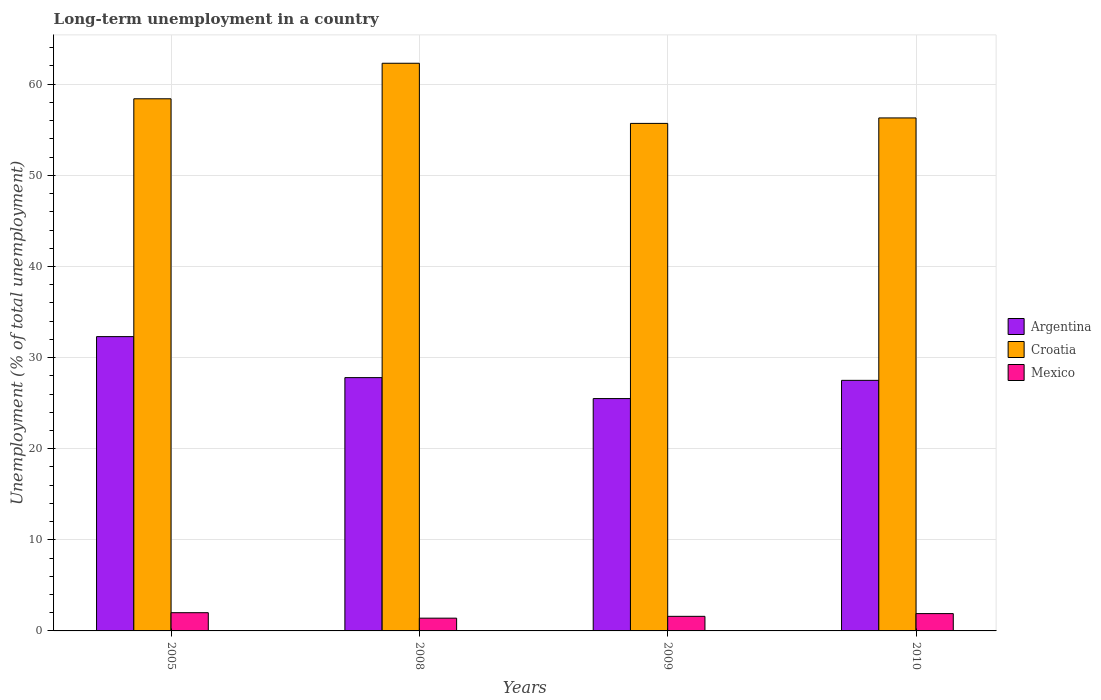How many different coloured bars are there?
Provide a short and direct response. 3. How many groups of bars are there?
Your answer should be compact. 4. Are the number of bars per tick equal to the number of legend labels?
Make the answer very short. Yes. Are the number of bars on each tick of the X-axis equal?
Provide a succinct answer. Yes. How many bars are there on the 4th tick from the right?
Your response must be concise. 3. What is the label of the 3rd group of bars from the left?
Make the answer very short. 2009. In how many cases, is the number of bars for a given year not equal to the number of legend labels?
Your response must be concise. 0. What is the percentage of long-term unemployed population in Mexico in 2010?
Provide a short and direct response. 1.9. Across all years, what is the maximum percentage of long-term unemployed population in Argentina?
Keep it short and to the point. 32.3. Across all years, what is the minimum percentage of long-term unemployed population in Mexico?
Make the answer very short. 1.4. In which year was the percentage of long-term unemployed population in Argentina minimum?
Ensure brevity in your answer.  2009. What is the total percentage of long-term unemployed population in Mexico in the graph?
Your response must be concise. 6.9. What is the difference between the percentage of long-term unemployed population in Croatia in 2008 and that in 2009?
Offer a terse response. 6.6. What is the difference between the percentage of long-term unemployed population in Mexico in 2008 and the percentage of long-term unemployed population in Croatia in 2010?
Offer a very short reply. -54.9. What is the average percentage of long-term unemployed population in Croatia per year?
Your response must be concise. 58.18. In the year 2009, what is the difference between the percentage of long-term unemployed population in Argentina and percentage of long-term unemployed population in Croatia?
Your response must be concise. -30.2. In how many years, is the percentage of long-term unemployed population in Mexico greater than 50 %?
Your answer should be very brief. 0. What is the ratio of the percentage of long-term unemployed population in Croatia in 2009 to that in 2010?
Provide a succinct answer. 0.99. What is the difference between the highest and the second highest percentage of long-term unemployed population in Mexico?
Provide a succinct answer. 0.1. What is the difference between the highest and the lowest percentage of long-term unemployed population in Mexico?
Keep it short and to the point. 0.6. Is it the case that in every year, the sum of the percentage of long-term unemployed population in Croatia and percentage of long-term unemployed population in Argentina is greater than the percentage of long-term unemployed population in Mexico?
Offer a very short reply. Yes. How many bars are there?
Your answer should be compact. 12. Are the values on the major ticks of Y-axis written in scientific E-notation?
Provide a short and direct response. No. Does the graph contain any zero values?
Offer a terse response. No. Does the graph contain grids?
Provide a succinct answer. Yes. Where does the legend appear in the graph?
Offer a terse response. Center right. How many legend labels are there?
Offer a terse response. 3. What is the title of the graph?
Provide a succinct answer. Long-term unemployment in a country. Does "Bosnia and Herzegovina" appear as one of the legend labels in the graph?
Keep it short and to the point. No. What is the label or title of the X-axis?
Your answer should be very brief. Years. What is the label or title of the Y-axis?
Offer a very short reply. Unemployment (% of total unemployment). What is the Unemployment (% of total unemployment) of Argentina in 2005?
Give a very brief answer. 32.3. What is the Unemployment (% of total unemployment) of Croatia in 2005?
Ensure brevity in your answer.  58.4. What is the Unemployment (% of total unemployment) of Mexico in 2005?
Offer a very short reply. 2. What is the Unemployment (% of total unemployment) of Argentina in 2008?
Make the answer very short. 27.8. What is the Unemployment (% of total unemployment) in Croatia in 2008?
Provide a succinct answer. 62.3. What is the Unemployment (% of total unemployment) in Mexico in 2008?
Offer a very short reply. 1.4. What is the Unemployment (% of total unemployment) in Croatia in 2009?
Your response must be concise. 55.7. What is the Unemployment (% of total unemployment) of Mexico in 2009?
Offer a very short reply. 1.6. What is the Unemployment (% of total unemployment) in Croatia in 2010?
Offer a very short reply. 56.3. What is the Unemployment (% of total unemployment) in Mexico in 2010?
Provide a short and direct response. 1.9. Across all years, what is the maximum Unemployment (% of total unemployment) in Argentina?
Provide a short and direct response. 32.3. Across all years, what is the maximum Unemployment (% of total unemployment) of Croatia?
Give a very brief answer. 62.3. Across all years, what is the maximum Unemployment (% of total unemployment) of Mexico?
Offer a terse response. 2. Across all years, what is the minimum Unemployment (% of total unemployment) of Croatia?
Offer a very short reply. 55.7. Across all years, what is the minimum Unemployment (% of total unemployment) of Mexico?
Provide a short and direct response. 1.4. What is the total Unemployment (% of total unemployment) of Argentina in the graph?
Ensure brevity in your answer.  113.1. What is the total Unemployment (% of total unemployment) in Croatia in the graph?
Provide a short and direct response. 232.7. What is the total Unemployment (% of total unemployment) in Mexico in the graph?
Offer a terse response. 6.9. What is the difference between the Unemployment (% of total unemployment) of Croatia in 2005 and that in 2008?
Give a very brief answer. -3.9. What is the difference between the Unemployment (% of total unemployment) of Mexico in 2005 and that in 2009?
Provide a short and direct response. 0.4. What is the difference between the Unemployment (% of total unemployment) of Argentina in 2005 and that in 2010?
Offer a terse response. 4.8. What is the difference between the Unemployment (% of total unemployment) of Argentina in 2008 and that in 2009?
Provide a short and direct response. 2.3. What is the difference between the Unemployment (% of total unemployment) in Mexico in 2008 and that in 2010?
Ensure brevity in your answer.  -0.5. What is the difference between the Unemployment (% of total unemployment) in Mexico in 2009 and that in 2010?
Your response must be concise. -0.3. What is the difference between the Unemployment (% of total unemployment) of Argentina in 2005 and the Unemployment (% of total unemployment) of Mexico in 2008?
Offer a terse response. 30.9. What is the difference between the Unemployment (% of total unemployment) in Croatia in 2005 and the Unemployment (% of total unemployment) in Mexico in 2008?
Provide a short and direct response. 57. What is the difference between the Unemployment (% of total unemployment) of Argentina in 2005 and the Unemployment (% of total unemployment) of Croatia in 2009?
Offer a very short reply. -23.4. What is the difference between the Unemployment (% of total unemployment) of Argentina in 2005 and the Unemployment (% of total unemployment) of Mexico in 2009?
Provide a succinct answer. 30.7. What is the difference between the Unemployment (% of total unemployment) of Croatia in 2005 and the Unemployment (% of total unemployment) of Mexico in 2009?
Provide a succinct answer. 56.8. What is the difference between the Unemployment (% of total unemployment) in Argentina in 2005 and the Unemployment (% of total unemployment) in Croatia in 2010?
Provide a succinct answer. -24. What is the difference between the Unemployment (% of total unemployment) in Argentina in 2005 and the Unemployment (% of total unemployment) in Mexico in 2010?
Provide a short and direct response. 30.4. What is the difference between the Unemployment (% of total unemployment) in Croatia in 2005 and the Unemployment (% of total unemployment) in Mexico in 2010?
Your response must be concise. 56.5. What is the difference between the Unemployment (% of total unemployment) in Argentina in 2008 and the Unemployment (% of total unemployment) in Croatia in 2009?
Ensure brevity in your answer.  -27.9. What is the difference between the Unemployment (% of total unemployment) of Argentina in 2008 and the Unemployment (% of total unemployment) of Mexico in 2009?
Your response must be concise. 26.2. What is the difference between the Unemployment (% of total unemployment) in Croatia in 2008 and the Unemployment (% of total unemployment) in Mexico in 2009?
Offer a terse response. 60.7. What is the difference between the Unemployment (% of total unemployment) in Argentina in 2008 and the Unemployment (% of total unemployment) in Croatia in 2010?
Offer a terse response. -28.5. What is the difference between the Unemployment (% of total unemployment) in Argentina in 2008 and the Unemployment (% of total unemployment) in Mexico in 2010?
Keep it short and to the point. 25.9. What is the difference between the Unemployment (% of total unemployment) in Croatia in 2008 and the Unemployment (% of total unemployment) in Mexico in 2010?
Provide a short and direct response. 60.4. What is the difference between the Unemployment (% of total unemployment) of Argentina in 2009 and the Unemployment (% of total unemployment) of Croatia in 2010?
Make the answer very short. -30.8. What is the difference between the Unemployment (% of total unemployment) of Argentina in 2009 and the Unemployment (% of total unemployment) of Mexico in 2010?
Offer a very short reply. 23.6. What is the difference between the Unemployment (% of total unemployment) in Croatia in 2009 and the Unemployment (% of total unemployment) in Mexico in 2010?
Ensure brevity in your answer.  53.8. What is the average Unemployment (% of total unemployment) in Argentina per year?
Provide a short and direct response. 28.27. What is the average Unemployment (% of total unemployment) of Croatia per year?
Provide a succinct answer. 58.17. What is the average Unemployment (% of total unemployment) of Mexico per year?
Offer a very short reply. 1.73. In the year 2005, what is the difference between the Unemployment (% of total unemployment) in Argentina and Unemployment (% of total unemployment) in Croatia?
Give a very brief answer. -26.1. In the year 2005, what is the difference between the Unemployment (% of total unemployment) of Argentina and Unemployment (% of total unemployment) of Mexico?
Give a very brief answer. 30.3. In the year 2005, what is the difference between the Unemployment (% of total unemployment) of Croatia and Unemployment (% of total unemployment) of Mexico?
Your answer should be compact. 56.4. In the year 2008, what is the difference between the Unemployment (% of total unemployment) of Argentina and Unemployment (% of total unemployment) of Croatia?
Your response must be concise. -34.5. In the year 2008, what is the difference between the Unemployment (% of total unemployment) of Argentina and Unemployment (% of total unemployment) of Mexico?
Your answer should be compact. 26.4. In the year 2008, what is the difference between the Unemployment (% of total unemployment) of Croatia and Unemployment (% of total unemployment) of Mexico?
Your answer should be compact. 60.9. In the year 2009, what is the difference between the Unemployment (% of total unemployment) of Argentina and Unemployment (% of total unemployment) of Croatia?
Ensure brevity in your answer.  -30.2. In the year 2009, what is the difference between the Unemployment (% of total unemployment) in Argentina and Unemployment (% of total unemployment) in Mexico?
Your answer should be very brief. 23.9. In the year 2009, what is the difference between the Unemployment (% of total unemployment) in Croatia and Unemployment (% of total unemployment) in Mexico?
Give a very brief answer. 54.1. In the year 2010, what is the difference between the Unemployment (% of total unemployment) in Argentina and Unemployment (% of total unemployment) in Croatia?
Make the answer very short. -28.8. In the year 2010, what is the difference between the Unemployment (% of total unemployment) in Argentina and Unemployment (% of total unemployment) in Mexico?
Provide a succinct answer. 25.6. In the year 2010, what is the difference between the Unemployment (% of total unemployment) of Croatia and Unemployment (% of total unemployment) of Mexico?
Keep it short and to the point. 54.4. What is the ratio of the Unemployment (% of total unemployment) in Argentina in 2005 to that in 2008?
Offer a very short reply. 1.16. What is the ratio of the Unemployment (% of total unemployment) of Croatia in 2005 to that in 2008?
Keep it short and to the point. 0.94. What is the ratio of the Unemployment (% of total unemployment) in Mexico in 2005 to that in 2008?
Give a very brief answer. 1.43. What is the ratio of the Unemployment (% of total unemployment) of Argentina in 2005 to that in 2009?
Your answer should be compact. 1.27. What is the ratio of the Unemployment (% of total unemployment) in Croatia in 2005 to that in 2009?
Ensure brevity in your answer.  1.05. What is the ratio of the Unemployment (% of total unemployment) in Mexico in 2005 to that in 2009?
Your answer should be very brief. 1.25. What is the ratio of the Unemployment (% of total unemployment) of Argentina in 2005 to that in 2010?
Offer a terse response. 1.17. What is the ratio of the Unemployment (% of total unemployment) of Croatia in 2005 to that in 2010?
Offer a terse response. 1.04. What is the ratio of the Unemployment (% of total unemployment) of Mexico in 2005 to that in 2010?
Your answer should be compact. 1.05. What is the ratio of the Unemployment (% of total unemployment) of Argentina in 2008 to that in 2009?
Keep it short and to the point. 1.09. What is the ratio of the Unemployment (% of total unemployment) of Croatia in 2008 to that in 2009?
Your answer should be compact. 1.12. What is the ratio of the Unemployment (% of total unemployment) of Argentina in 2008 to that in 2010?
Offer a very short reply. 1.01. What is the ratio of the Unemployment (% of total unemployment) of Croatia in 2008 to that in 2010?
Your response must be concise. 1.11. What is the ratio of the Unemployment (% of total unemployment) in Mexico in 2008 to that in 2010?
Provide a succinct answer. 0.74. What is the ratio of the Unemployment (% of total unemployment) in Argentina in 2009 to that in 2010?
Make the answer very short. 0.93. What is the ratio of the Unemployment (% of total unemployment) of Croatia in 2009 to that in 2010?
Provide a succinct answer. 0.99. What is the ratio of the Unemployment (% of total unemployment) of Mexico in 2009 to that in 2010?
Offer a very short reply. 0.84. What is the difference between the highest and the second highest Unemployment (% of total unemployment) in Croatia?
Make the answer very short. 3.9. What is the difference between the highest and the second highest Unemployment (% of total unemployment) in Mexico?
Offer a very short reply. 0.1. What is the difference between the highest and the lowest Unemployment (% of total unemployment) of Argentina?
Offer a very short reply. 6.8. What is the difference between the highest and the lowest Unemployment (% of total unemployment) of Croatia?
Provide a short and direct response. 6.6. What is the difference between the highest and the lowest Unemployment (% of total unemployment) of Mexico?
Ensure brevity in your answer.  0.6. 